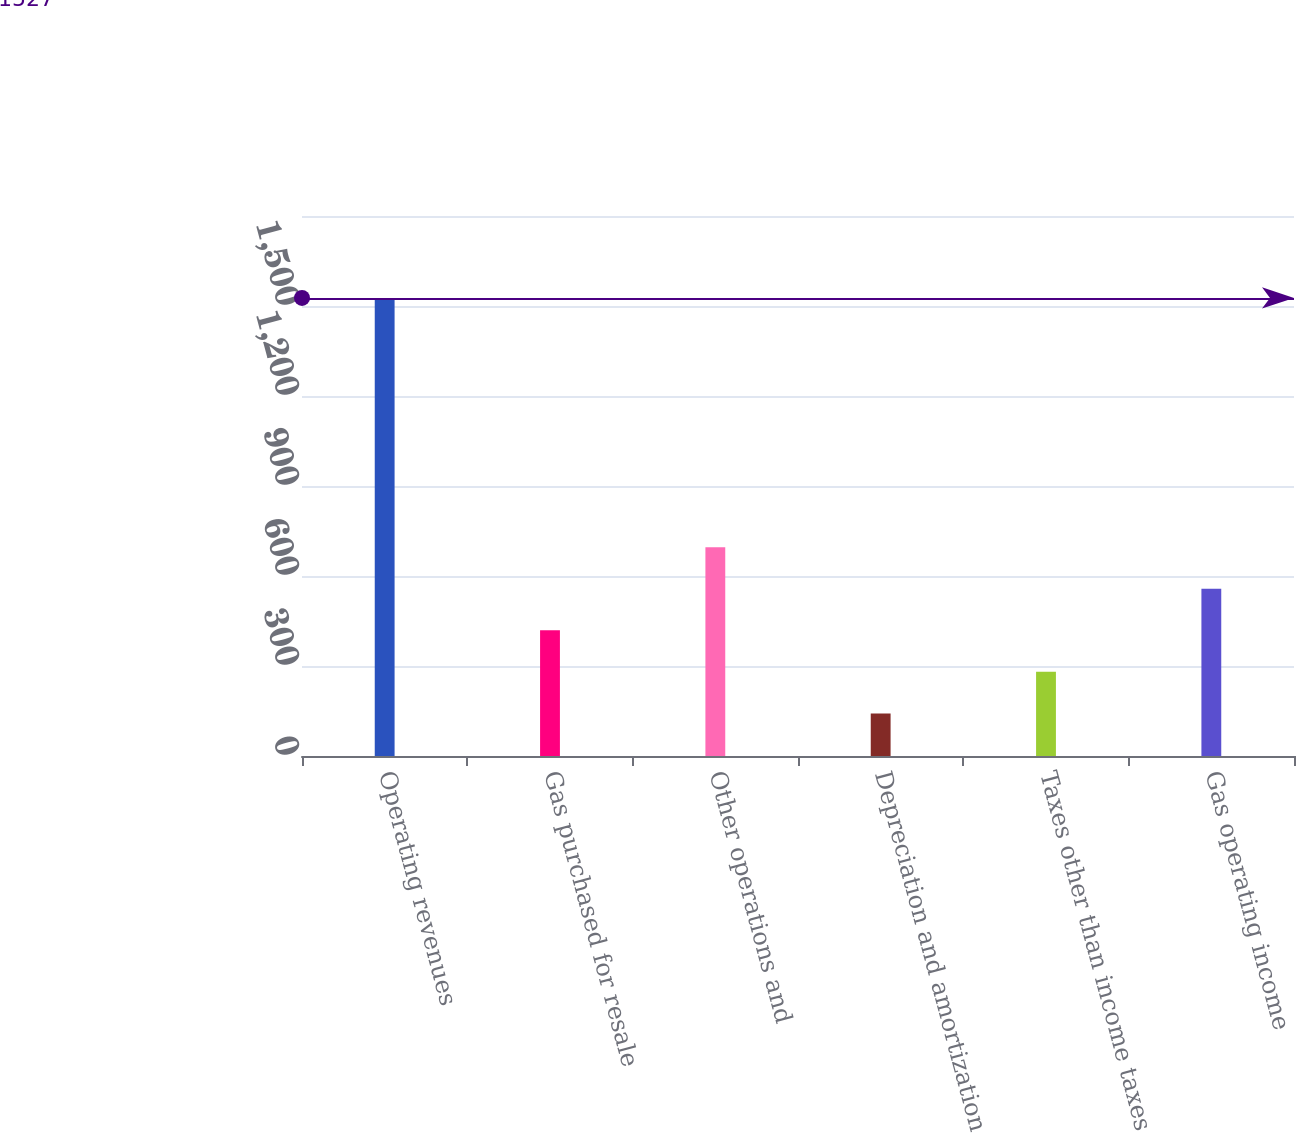Convert chart. <chart><loc_0><loc_0><loc_500><loc_500><bar_chart><fcel>Operating revenues<fcel>Gas purchased for resale<fcel>Other operations and<fcel>Depreciation and amortization<fcel>Taxes other than income taxes<fcel>Gas operating income<nl><fcel>1527<fcel>419<fcel>696<fcel>142<fcel>280.5<fcel>557.5<nl></chart> 